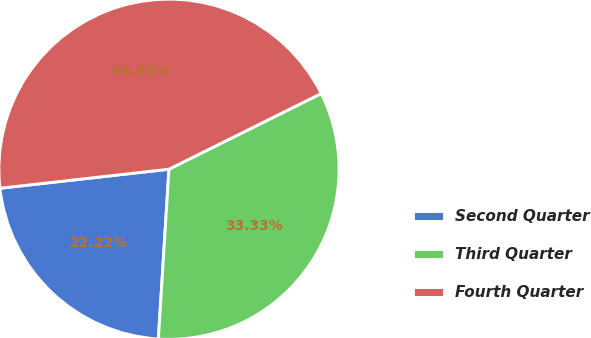<chart> <loc_0><loc_0><loc_500><loc_500><pie_chart><fcel>Second Quarter<fcel>Third Quarter<fcel>Fourth Quarter<nl><fcel>22.22%<fcel>33.33%<fcel>44.44%<nl></chart> 